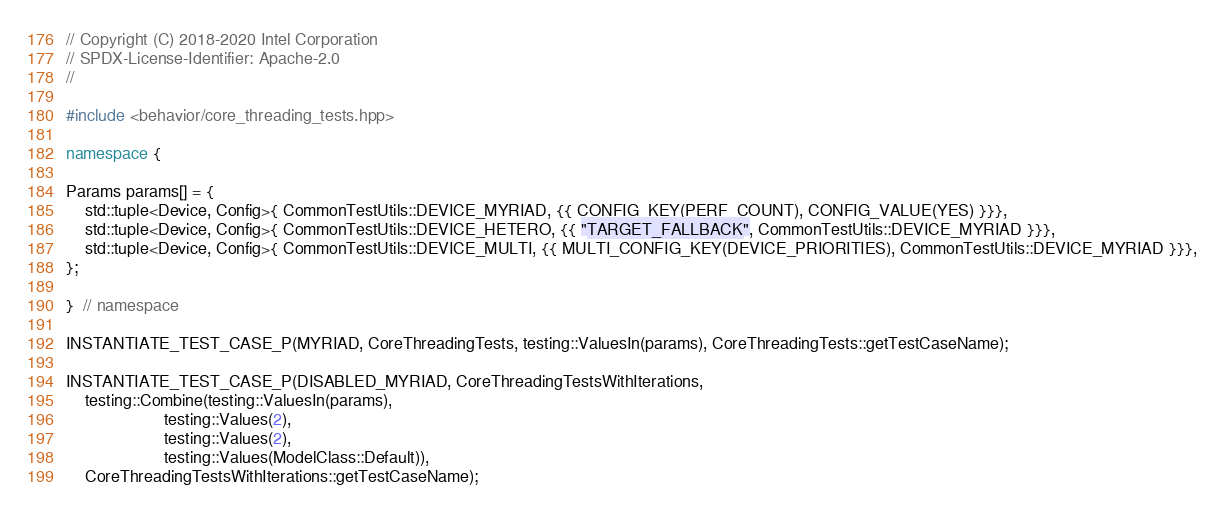Convert code to text. <code><loc_0><loc_0><loc_500><loc_500><_C++_>// Copyright (C) 2018-2020 Intel Corporation
// SPDX-License-Identifier: Apache-2.0
//

#include <behavior/core_threading_tests.hpp>

namespace {

Params params[] = {
    std::tuple<Device, Config>{ CommonTestUtils::DEVICE_MYRIAD, {{ CONFIG_KEY(PERF_COUNT), CONFIG_VALUE(YES) }}},
    std::tuple<Device, Config>{ CommonTestUtils::DEVICE_HETERO, {{ "TARGET_FALLBACK", CommonTestUtils::DEVICE_MYRIAD }}},
    std::tuple<Device, Config>{ CommonTestUtils::DEVICE_MULTI, {{ MULTI_CONFIG_KEY(DEVICE_PRIORITIES), CommonTestUtils::DEVICE_MYRIAD }}},
};

}  // namespace

INSTANTIATE_TEST_CASE_P(MYRIAD, CoreThreadingTests, testing::ValuesIn(params), CoreThreadingTests::getTestCaseName);

INSTANTIATE_TEST_CASE_P(DISABLED_MYRIAD, CoreThreadingTestsWithIterations,
    testing::Combine(testing::ValuesIn(params),
                     testing::Values(2),
                     testing::Values(2),
                     testing::Values(ModelClass::Default)),
    CoreThreadingTestsWithIterations::getTestCaseName);
</code> 